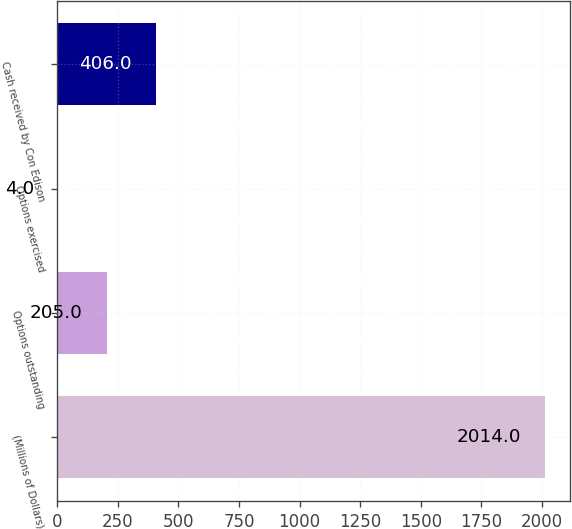Convert chart. <chart><loc_0><loc_0><loc_500><loc_500><bar_chart><fcel>(Millions of Dollars)<fcel>Options outstanding<fcel>Options exercised<fcel>Cash received by Con Edison<nl><fcel>2014<fcel>205<fcel>4<fcel>406<nl></chart> 